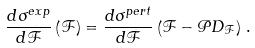<formula> <loc_0><loc_0><loc_500><loc_500>\frac { d \sigma ^ { e x p } } { d { \mathcal { F } } } \left ( \mathcal { F } \right ) = { \frac { d \sigma ^ { p e r t } } { d { \mathcal { F } } } } \left ( \mathcal { F } - \mathcal { P } D _ { \mathcal { F } } \right ) \, .</formula> 